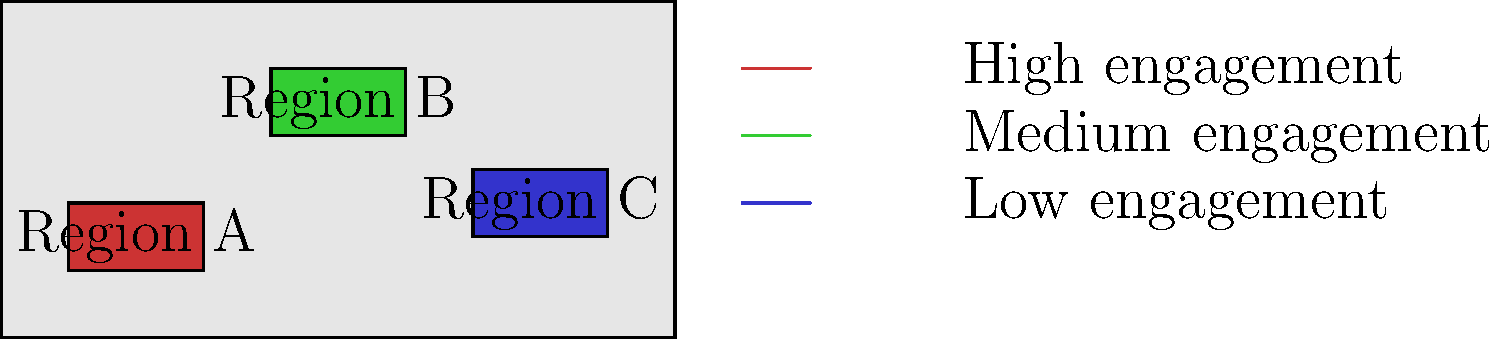Based on the world map showing the global reach of your online fundraising campaign for human rights causes, which region has the highest level of engagement, and what strategic decision would you make to optimize your campaign's impact? 1. Analyze the map:
   - The map shows three highlighted regions: A, B, and C.
   - Each region is color-coded to represent different levels of engagement.

2. Interpret the legend:
   - Red (Region A) represents high engagement.
   - Green (Region B) represents medium engagement.
   - Blue (Region C) represents low engagement.

3. Identify the region with the highest engagement:
   - Region A is colored red, indicating the highest level of engagement.

4. Consider strategic decisions:
   - Focus on Region A to maintain and amplify high engagement.
   - Allocate more resources to Region B to potentially elevate it to high engagement.
   - Develop targeted strategies for Region C to increase engagement.

5. Optimize campaign impact:
   - Concentrate on Region A by:
     a) Creating region-specific content that resonates with the local audience.
     b) Implementing referral programs to leverage the existing high engagement.
     c) Organizing virtual events or webinars tailored to this region's interests.

6. Conclusion:
   The strategic decision would be to prioritize resources and attention on Region A to maximize the campaign's impact, while developing strategies to improve engagement in the other regions.
Answer: Prioritize Region A with tailored content and referral programs. 